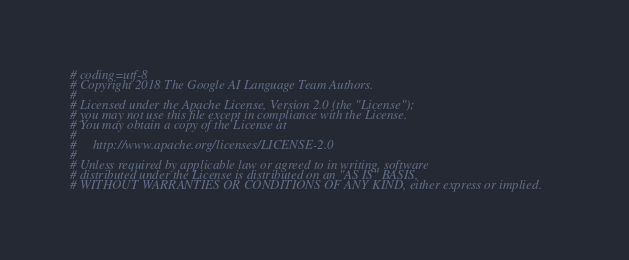Convert code to text. <code><loc_0><loc_0><loc_500><loc_500><_Python_># coding=utf-8
# Copyright 2018 The Google AI Language Team Authors.
#
# Licensed under the Apache License, Version 2.0 (the "License");
# you may not use this file except in compliance with the License.
# You may obtain a copy of the License at
#
#     http://www.apache.org/licenses/LICENSE-2.0
#
# Unless required by applicable law or agreed to in writing, software
# distributed under the License is distributed on an "AS IS" BASIS,
# WITHOUT WARRANTIES OR CONDITIONS OF ANY KIND, either express or implied.</code> 